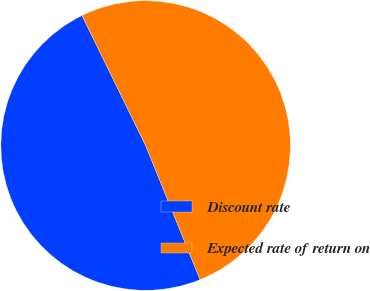Convert chart to OTSL. <chart><loc_0><loc_0><loc_500><loc_500><pie_chart><fcel>Discount rate<fcel>Expected rate of return on<nl><fcel>48.89%<fcel>51.11%<nl></chart> 